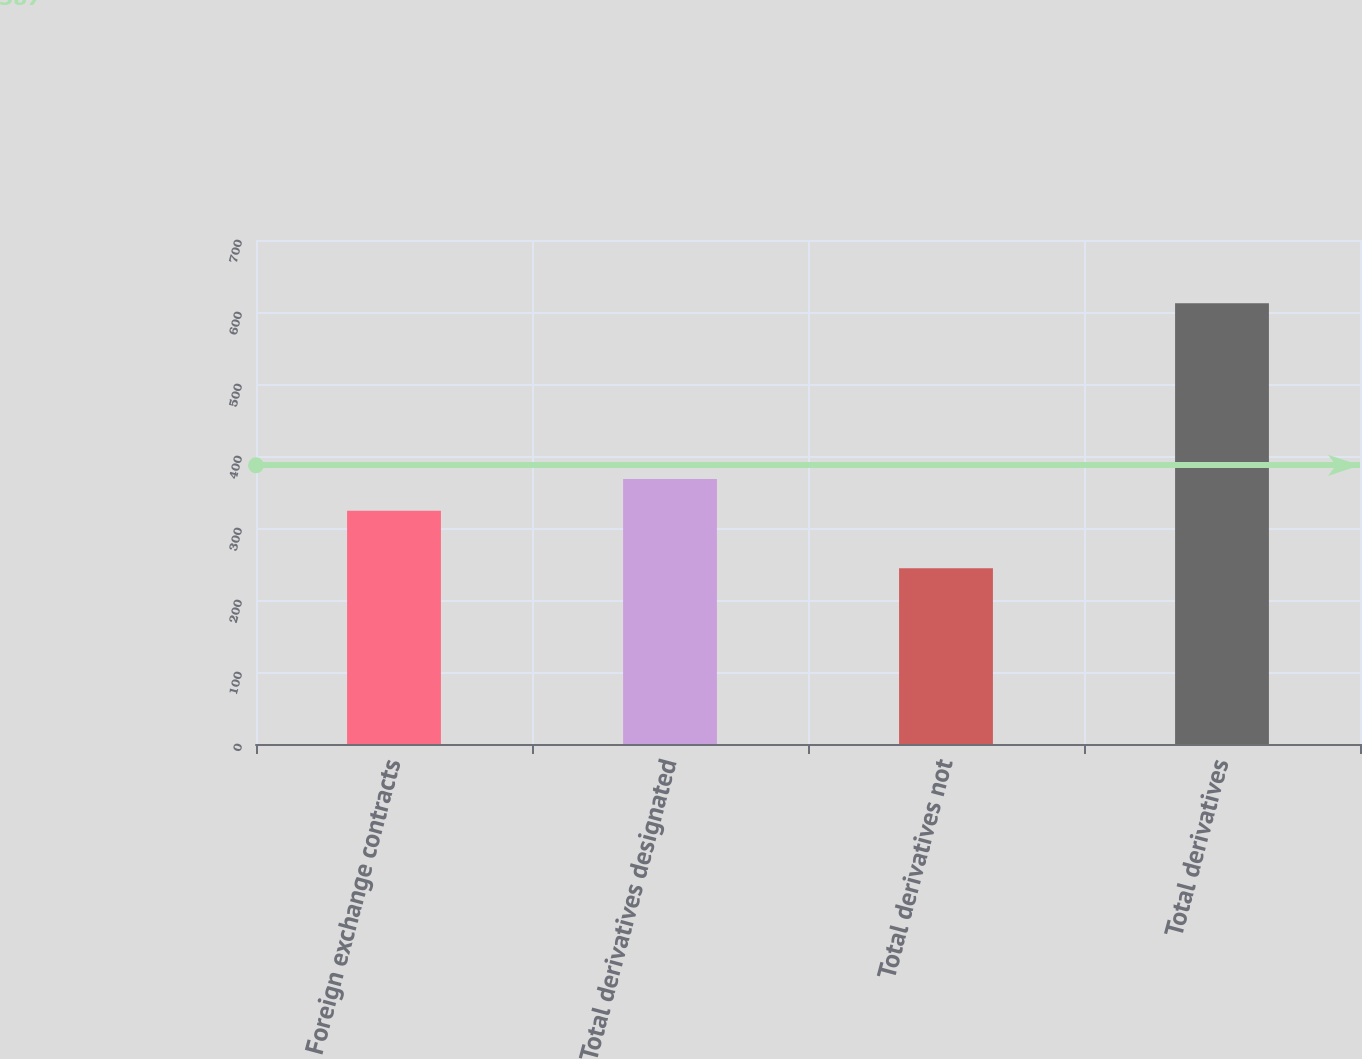<chart> <loc_0><loc_0><loc_500><loc_500><bar_chart><fcel>Foreign exchange contracts<fcel>Total derivatives designated<fcel>Total derivatives not<fcel>Total derivatives<nl><fcel>324<fcel>368<fcel>244<fcel>612<nl></chart> 